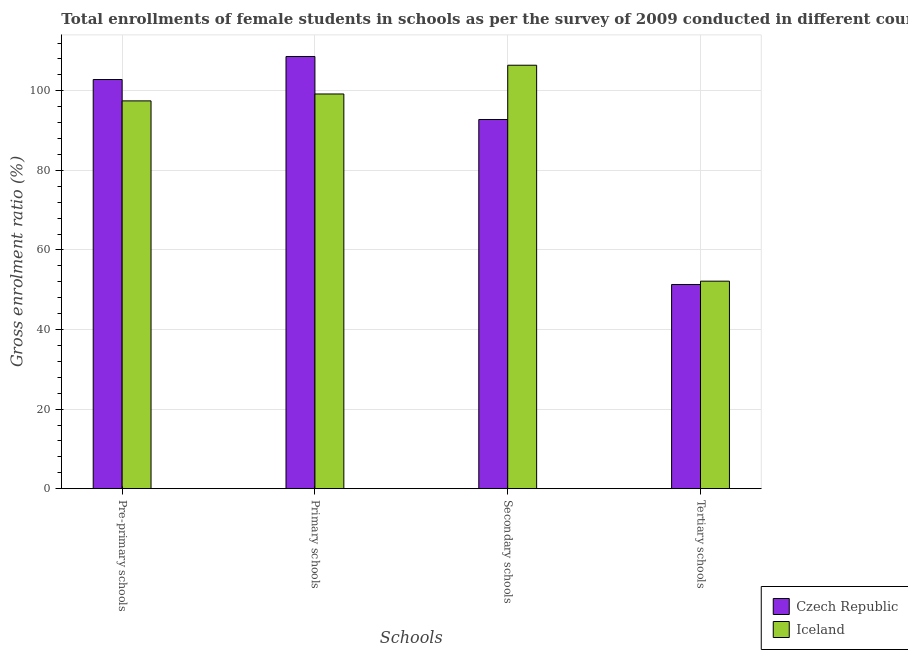How many different coloured bars are there?
Provide a short and direct response. 2. How many groups of bars are there?
Offer a terse response. 4. Are the number of bars on each tick of the X-axis equal?
Your answer should be compact. Yes. What is the label of the 4th group of bars from the left?
Give a very brief answer. Tertiary schools. What is the gross enrolment ratio(female) in primary schools in Iceland?
Your response must be concise. 99.2. Across all countries, what is the maximum gross enrolment ratio(female) in secondary schools?
Your answer should be very brief. 106.43. Across all countries, what is the minimum gross enrolment ratio(female) in primary schools?
Your answer should be compact. 99.2. In which country was the gross enrolment ratio(female) in primary schools maximum?
Keep it short and to the point. Czech Republic. In which country was the gross enrolment ratio(female) in tertiary schools minimum?
Your answer should be compact. Czech Republic. What is the total gross enrolment ratio(female) in secondary schools in the graph?
Your answer should be compact. 199.22. What is the difference between the gross enrolment ratio(female) in tertiary schools in Iceland and that in Czech Republic?
Provide a succinct answer. 0.84. What is the difference between the gross enrolment ratio(female) in secondary schools in Czech Republic and the gross enrolment ratio(female) in tertiary schools in Iceland?
Your response must be concise. 40.63. What is the average gross enrolment ratio(female) in tertiary schools per country?
Your answer should be compact. 51.74. What is the difference between the gross enrolment ratio(female) in pre-primary schools and gross enrolment ratio(female) in tertiary schools in Czech Republic?
Provide a succinct answer. 51.52. What is the ratio of the gross enrolment ratio(female) in tertiary schools in Iceland to that in Czech Republic?
Ensure brevity in your answer.  1.02. What is the difference between the highest and the second highest gross enrolment ratio(female) in pre-primary schools?
Your answer should be very brief. 5.37. What is the difference between the highest and the lowest gross enrolment ratio(female) in secondary schools?
Your answer should be compact. 13.64. In how many countries, is the gross enrolment ratio(female) in secondary schools greater than the average gross enrolment ratio(female) in secondary schools taken over all countries?
Offer a very short reply. 1. What does the 1st bar from the left in Primary schools represents?
Make the answer very short. Czech Republic. What does the 2nd bar from the right in Primary schools represents?
Your answer should be very brief. Czech Republic. Are the values on the major ticks of Y-axis written in scientific E-notation?
Keep it short and to the point. No. Does the graph contain any zero values?
Make the answer very short. No. Where does the legend appear in the graph?
Your response must be concise. Bottom right. How are the legend labels stacked?
Offer a terse response. Vertical. What is the title of the graph?
Offer a very short reply. Total enrollments of female students in schools as per the survey of 2009 conducted in different countries. What is the label or title of the X-axis?
Provide a succinct answer. Schools. What is the Gross enrolment ratio (%) of Czech Republic in Pre-primary schools?
Your answer should be compact. 102.84. What is the Gross enrolment ratio (%) in Iceland in Pre-primary schools?
Give a very brief answer. 97.47. What is the Gross enrolment ratio (%) of Czech Republic in Primary schools?
Ensure brevity in your answer.  108.63. What is the Gross enrolment ratio (%) of Iceland in Primary schools?
Provide a short and direct response. 99.2. What is the Gross enrolment ratio (%) in Czech Republic in Secondary schools?
Offer a terse response. 92.79. What is the Gross enrolment ratio (%) of Iceland in Secondary schools?
Provide a succinct answer. 106.43. What is the Gross enrolment ratio (%) in Czech Republic in Tertiary schools?
Make the answer very short. 51.32. What is the Gross enrolment ratio (%) in Iceland in Tertiary schools?
Offer a terse response. 52.16. Across all Schools, what is the maximum Gross enrolment ratio (%) in Czech Republic?
Keep it short and to the point. 108.63. Across all Schools, what is the maximum Gross enrolment ratio (%) in Iceland?
Provide a short and direct response. 106.43. Across all Schools, what is the minimum Gross enrolment ratio (%) in Czech Republic?
Your answer should be compact. 51.32. Across all Schools, what is the minimum Gross enrolment ratio (%) of Iceland?
Offer a terse response. 52.16. What is the total Gross enrolment ratio (%) in Czech Republic in the graph?
Offer a terse response. 355.58. What is the total Gross enrolment ratio (%) of Iceland in the graph?
Your response must be concise. 355.26. What is the difference between the Gross enrolment ratio (%) in Czech Republic in Pre-primary schools and that in Primary schools?
Offer a terse response. -5.79. What is the difference between the Gross enrolment ratio (%) of Iceland in Pre-primary schools and that in Primary schools?
Your answer should be compact. -1.74. What is the difference between the Gross enrolment ratio (%) of Czech Republic in Pre-primary schools and that in Secondary schools?
Offer a terse response. 10.05. What is the difference between the Gross enrolment ratio (%) in Iceland in Pre-primary schools and that in Secondary schools?
Ensure brevity in your answer.  -8.96. What is the difference between the Gross enrolment ratio (%) of Czech Republic in Pre-primary schools and that in Tertiary schools?
Offer a terse response. 51.52. What is the difference between the Gross enrolment ratio (%) in Iceland in Pre-primary schools and that in Tertiary schools?
Ensure brevity in your answer.  45.31. What is the difference between the Gross enrolment ratio (%) of Czech Republic in Primary schools and that in Secondary schools?
Provide a succinct answer. 15.84. What is the difference between the Gross enrolment ratio (%) in Iceland in Primary schools and that in Secondary schools?
Offer a very short reply. -7.23. What is the difference between the Gross enrolment ratio (%) in Czech Republic in Primary schools and that in Tertiary schools?
Keep it short and to the point. 57.31. What is the difference between the Gross enrolment ratio (%) in Iceland in Primary schools and that in Tertiary schools?
Your response must be concise. 47.05. What is the difference between the Gross enrolment ratio (%) of Czech Republic in Secondary schools and that in Tertiary schools?
Offer a very short reply. 41.47. What is the difference between the Gross enrolment ratio (%) of Iceland in Secondary schools and that in Tertiary schools?
Provide a short and direct response. 54.27. What is the difference between the Gross enrolment ratio (%) in Czech Republic in Pre-primary schools and the Gross enrolment ratio (%) in Iceland in Primary schools?
Ensure brevity in your answer.  3.63. What is the difference between the Gross enrolment ratio (%) in Czech Republic in Pre-primary schools and the Gross enrolment ratio (%) in Iceland in Secondary schools?
Make the answer very short. -3.59. What is the difference between the Gross enrolment ratio (%) in Czech Republic in Pre-primary schools and the Gross enrolment ratio (%) in Iceland in Tertiary schools?
Your answer should be very brief. 50.68. What is the difference between the Gross enrolment ratio (%) of Czech Republic in Primary schools and the Gross enrolment ratio (%) of Iceland in Secondary schools?
Ensure brevity in your answer.  2.2. What is the difference between the Gross enrolment ratio (%) of Czech Republic in Primary schools and the Gross enrolment ratio (%) of Iceland in Tertiary schools?
Provide a succinct answer. 56.47. What is the difference between the Gross enrolment ratio (%) of Czech Republic in Secondary schools and the Gross enrolment ratio (%) of Iceland in Tertiary schools?
Offer a terse response. 40.63. What is the average Gross enrolment ratio (%) of Czech Republic per Schools?
Give a very brief answer. 88.89. What is the average Gross enrolment ratio (%) of Iceland per Schools?
Provide a succinct answer. 88.81. What is the difference between the Gross enrolment ratio (%) in Czech Republic and Gross enrolment ratio (%) in Iceland in Pre-primary schools?
Make the answer very short. 5.37. What is the difference between the Gross enrolment ratio (%) in Czech Republic and Gross enrolment ratio (%) in Iceland in Primary schools?
Your answer should be very brief. 9.42. What is the difference between the Gross enrolment ratio (%) of Czech Republic and Gross enrolment ratio (%) of Iceland in Secondary schools?
Ensure brevity in your answer.  -13.64. What is the difference between the Gross enrolment ratio (%) in Czech Republic and Gross enrolment ratio (%) in Iceland in Tertiary schools?
Your response must be concise. -0.84. What is the ratio of the Gross enrolment ratio (%) of Czech Republic in Pre-primary schools to that in Primary schools?
Make the answer very short. 0.95. What is the ratio of the Gross enrolment ratio (%) in Iceland in Pre-primary schools to that in Primary schools?
Your answer should be compact. 0.98. What is the ratio of the Gross enrolment ratio (%) in Czech Republic in Pre-primary schools to that in Secondary schools?
Your answer should be very brief. 1.11. What is the ratio of the Gross enrolment ratio (%) of Iceland in Pre-primary schools to that in Secondary schools?
Give a very brief answer. 0.92. What is the ratio of the Gross enrolment ratio (%) in Czech Republic in Pre-primary schools to that in Tertiary schools?
Your answer should be very brief. 2. What is the ratio of the Gross enrolment ratio (%) in Iceland in Pre-primary schools to that in Tertiary schools?
Offer a terse response. 1.87. What is the ratio of the Gross enrolment ratio (%) of Czech Republic in Primary schools to that in Secondary schools?
Ensure brevity in your answer.  1.17. What is the ratio of the Gross enrolment ratio (%) of Iceland in Primary schools to that in Secondary schools?
Your answer should be compact. 0.93. What is the ratio of the Gross enrolment ratio (%) in Czech Republic in Primary schools to that in Tertiary schools?
Provide a short and direct response. 2.12. What is the ratio of the Gross enrolment ratio (%) in Iceland in Primary schools to that in Tertiary schools?
Your answer should be compact. 1.9. What is the ratio of the Gross enrolment ratio (%) of Czech Republic in Secondary schools to that in Tertiary schools?
Your response must be concise. 1.81. What is the ratio of the Gross enrolment ratio (%) in Iceland in Secondary schools to that in Tertiary schools?
Offer a very short reply. 2.04. What is the difference between the highest and the second highest Gross enrolment ratio (%) of Czech Republic?
Ensure brevity in your answer.  5.79. What is the difference between the highest and the second highest Gross enrolment ratio (%) in Iceland?
Your response must be concise. 7.23. What is the difference between the highest and the lowest Gross enrolment ratio (%) in Czech Republic?
Keep it short and to the point. 57.31. What is the difference between the highest and the lowest Gross enrolment ratio (%) of Iceland?
Keep it short and to the point. 54.27. 